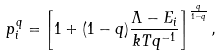<formula> <loc_0><loc_0><loc_500><loc_500>p _ { i } ^ { q } = \left [ 1 + ( 1 - q ) \frac { \Lambda - E _ { i } } { k T q ^ { - 1 } } \right ] ^ { \frac { q } { 1 - q } } ,</formula> 